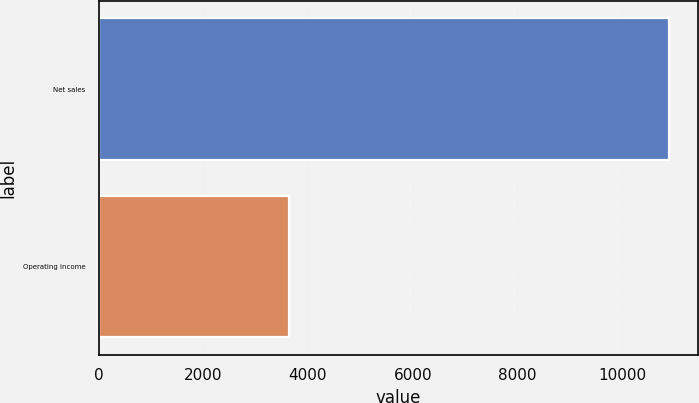<chart> <loc_0><loc_0><loc_500><loc_500><bar_chart><fcel>Net sales<fcel>Operating income<nl><fcel>10903<fcel>3634<nl></chart> 